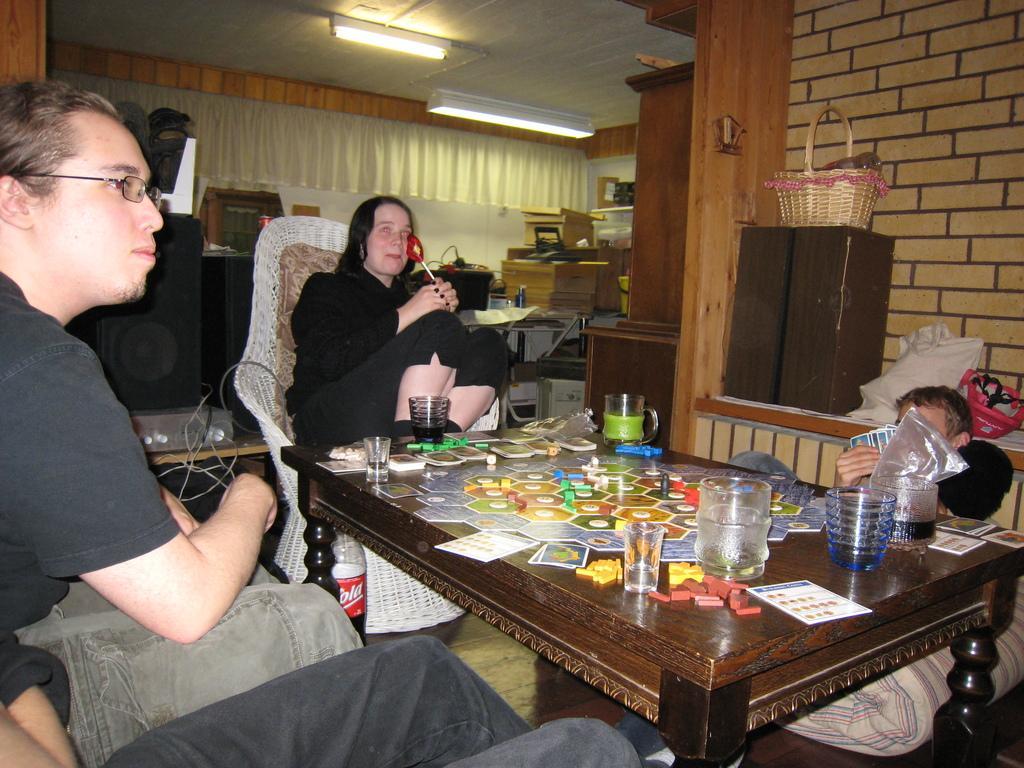How would you summarize this image in a sentence or two? In this picture we can see two persons sitting on the chairs. This is table. On the table there are glasses, cards, and jar. On the background there is a wall and this is cupboard. Here we can see a basket. This is curtain and these are the lights. 